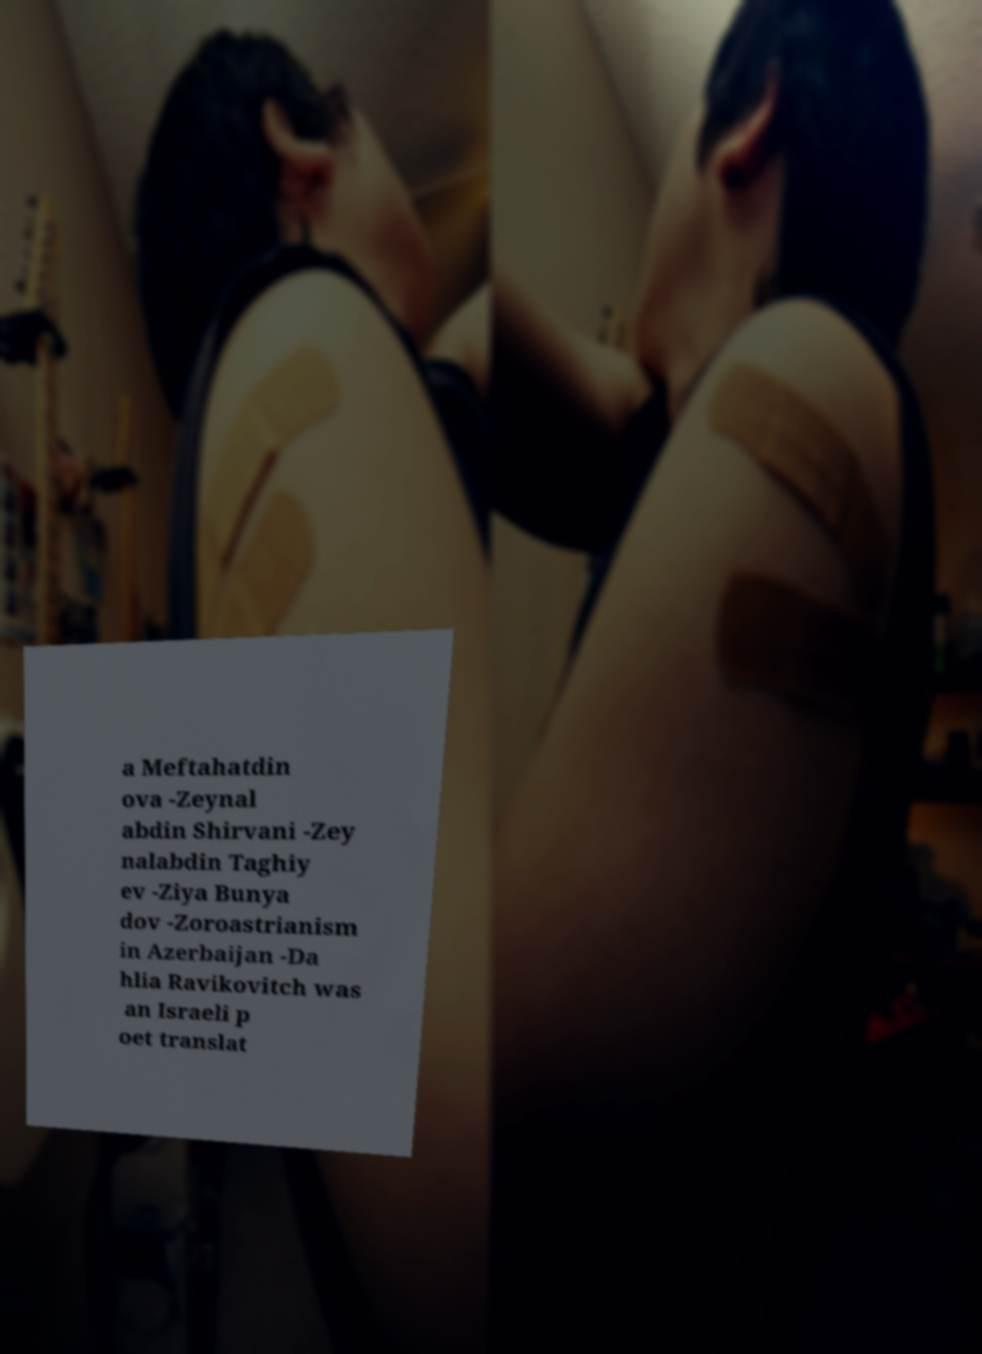I need the written content from this picture converted into text. Can you do that? a Meftahatdin ova -Zeynal abdin Shirvani -Zey nalabdin Taghiy ev -Ziya Bunya dov -Zoroastrianism in Azerbaijan -Da hlia Ravikovitch was an Israeli p oet translat 